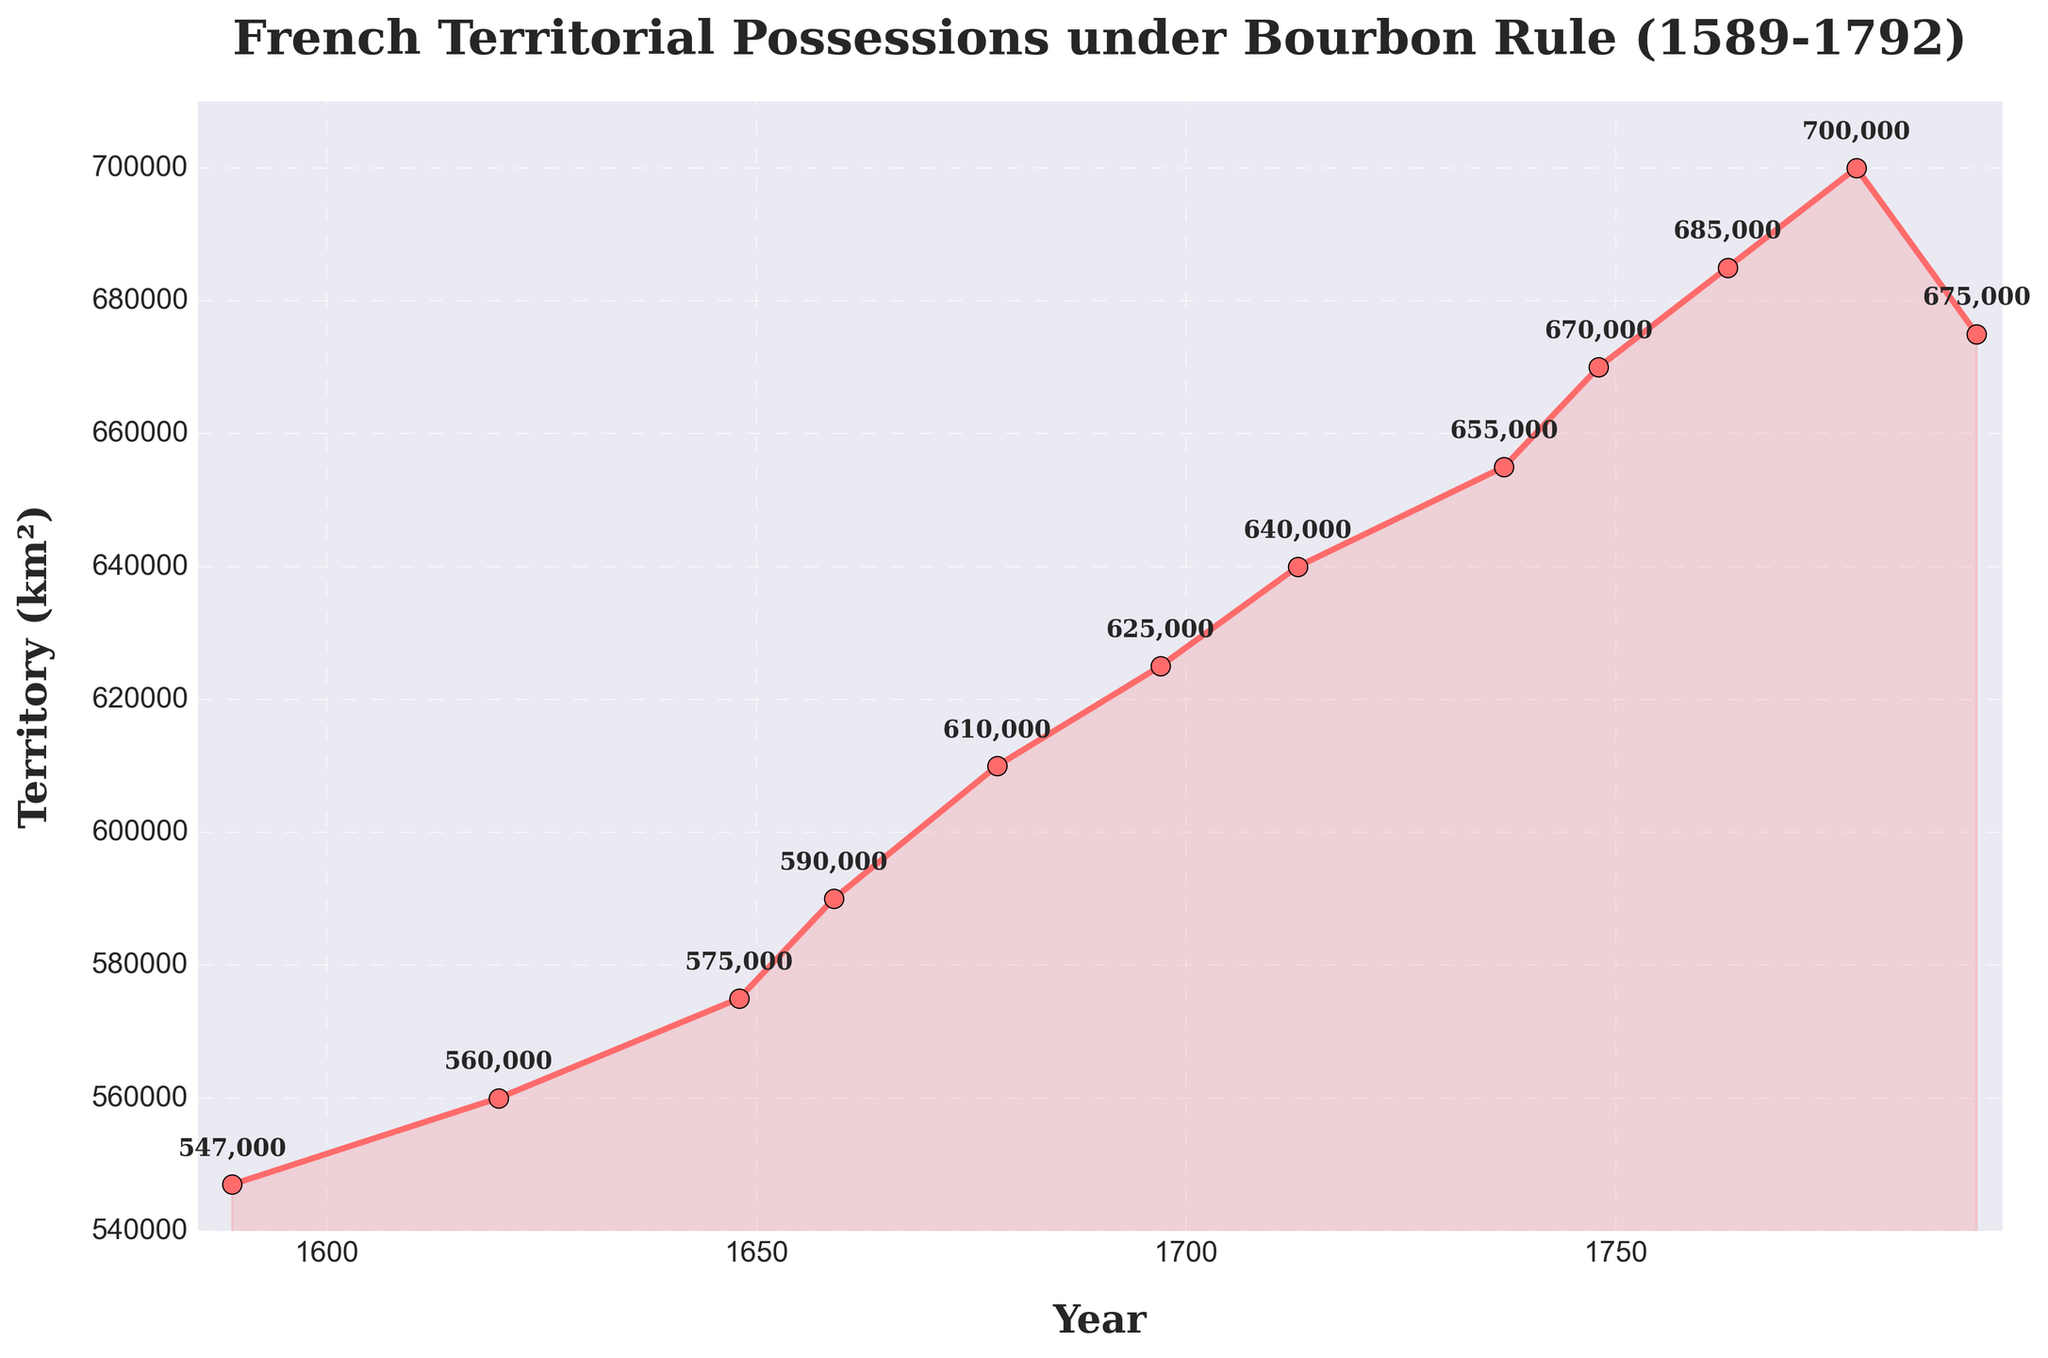How did the French territorial possessions change between 1589 and 1792? To answer this, observe the overall trend of the line chart. Starting from 547,000 km² in 1589, the territory gradually increased over the centuries, peaking at 700,000 km² in 1778, and then slightly decreasing to 675,000 km² in 1792.
Answer: They increased overall What was the peak territorial possession of France under Bourbon rule? Identify the highest point on the line chart, marked at 700,000 km² in the year 1778.
Answer: 700,000 km² How much did the territorial possessions increase from 1589 to 1778? Subtract the territory in 1589 (547,000 km²) from the territory in 1778 (700,000 km²): 700,000 km² - 547,000 km² = 153,000 km².
Answer: 153,000 km² Which year marked the peak in territorial expansion, and by how much did it decline by 1792? The peak was in 1778 at 700,000 km². The territory in 1792 was 675,000 km². Subtract the latter from the former: 700,000 km² - 675,000 km² = 25,000 km².
Answer: 1778; 25,000 km² Between which years did the French territory experience the largest increase? Compare the increments over different periods. From 1737 to 1748, the territory increased from 655,000 km² to 670,000 km², an increase of 15,000 km². This is the largest increase observed.
Answer: 1737 to 1748 What is the average territorial possession between 1589 and 1792? Add all the territorial values: (547000 + 560000 + 575000 + 590000 + 610000 + 625000 + 640000 + 655000 + 670000 + 685000 + 700000 + 675000) = 8432000 km². Divide by the number of years (12): 8432000 / 12 ≈ 702,667 km².
Answer: ≈ 702,667 km² Which period saw the smallest increase in territorial possessions? Observe the incremental changes. The smallest increase was from 1620 (560,000 km²) to 1648 (575,000 km²), an increase of 15,000 km².
Answer: 1620 to 1648 Did the territory ever decrease between any recorded years? Identify any declining segments in the line chart. The only decrease occurred between 1778 (700,000 km²) and 1792 (675,000 km²).
Answer: Yes, 1778 to 1792 How many periods saw a steady increase in territorial possessions? Count the number of continuous periods where the territory increased. All periods except 1778 to 1792 saw an increase, so 10 periods.
Answer: 10 periods 